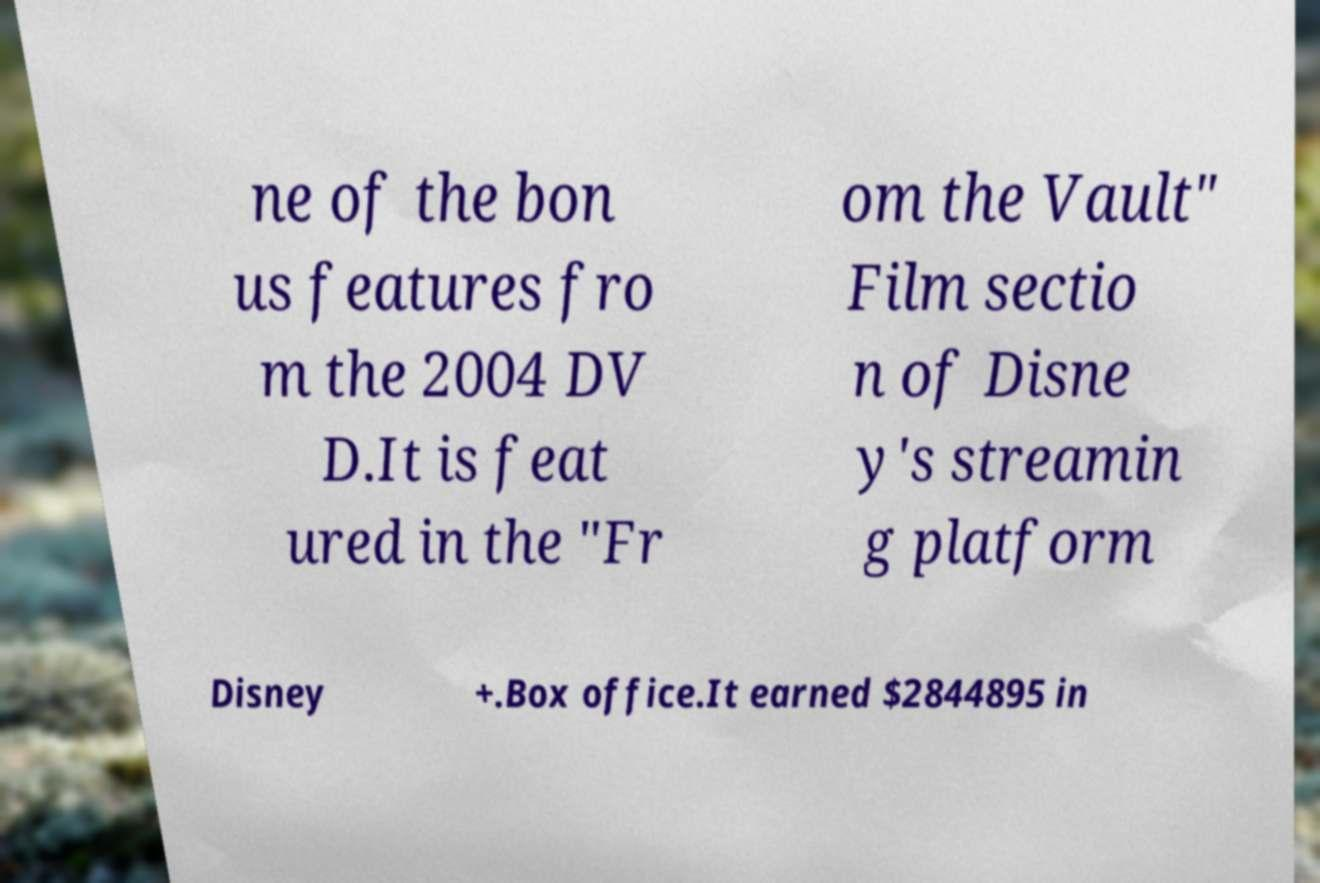I need the written content from this picture converted into text. Can you do that? ne of the bon us features fro m the 2004 DV D.It is feat ured in the "Fr om the Vault" Film sectio n of Disne y's streamin g platform Disney +.Box office.It earned $2844895 in 